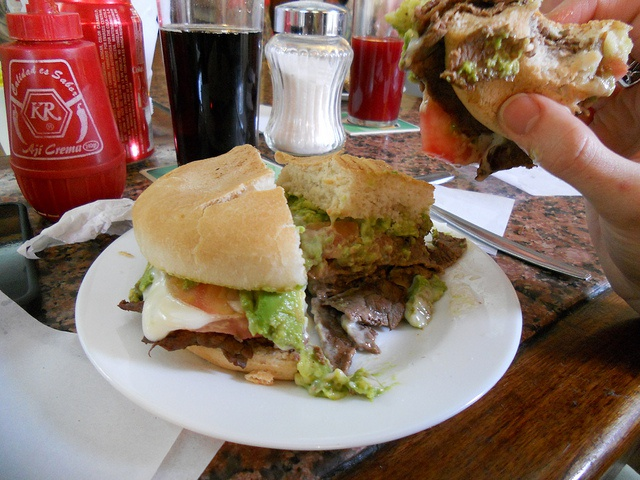Describe the objects in this image and their specific colors. I can see dining table in gray, lightgray, darkgray, maroon, and black tones, sandwich in gray, tan, olive, and maroon tones, sandwich in gray, maroon, brown, black, and olive tones, bottle in gray, brown, and maroon tones, and people in gray, maroon, and brown tones in this image. 